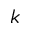<formula> <loc_0><loc_0><loc_500><loc_500>k</formula> 